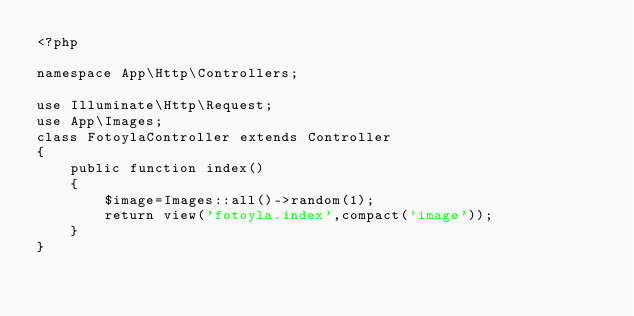<code> <loc_0><loc_0><loc_500><loc_500><_PHP_><?php

namespace App\Http\Controllers;

use Illuminate\Http\Request;
use App\Images;
class FotoylaController extends Controller
{
    public function index()
    {
        $image=Images::all()->random(1);
        return view('fotoyla.index',compact('image'));
    }
}
</code> 